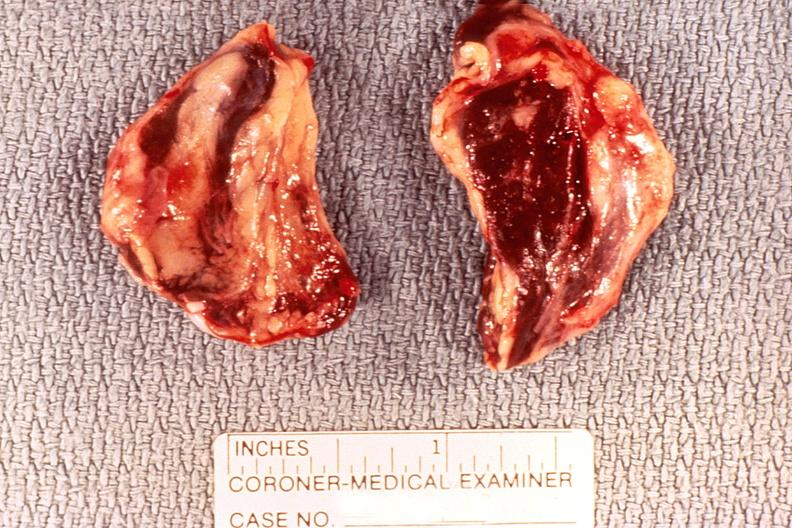what does this image show?
Answer the question using a single word or phrase. Adrenal gland 